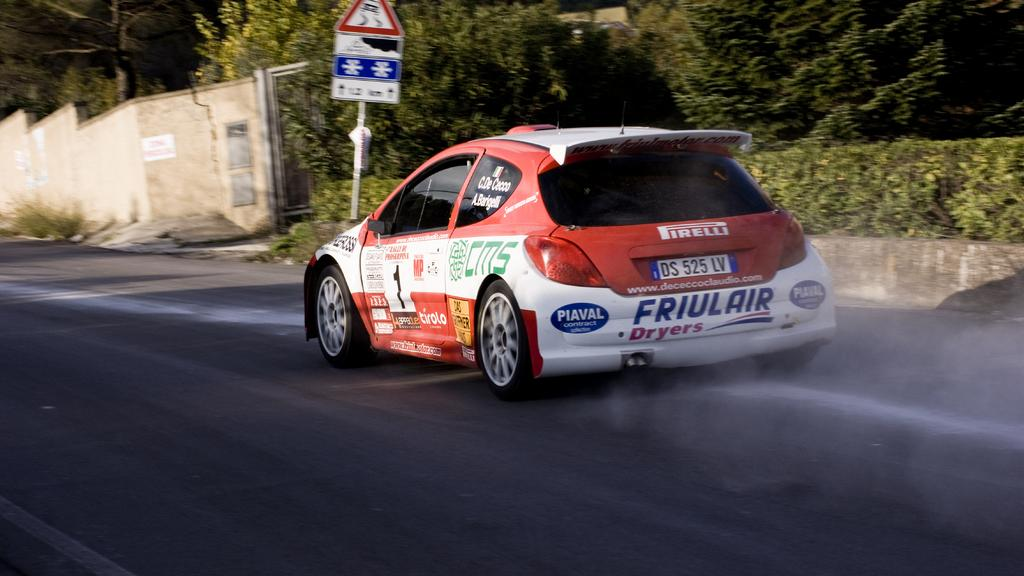What is on the road in the image? There is a vehicle on the road in the image. What structure can be seen in the image? There is a wall in the image. What is attached to the pole in the image? There are boards attached to the pole in the image. What type of vegetation is visible in the background of the image? There are plants and trees in the background of the image. What type of organization is advertised on the sign in the image? There is no sign present in the image, so it is not possible to determine what type of organization might be advertised. 